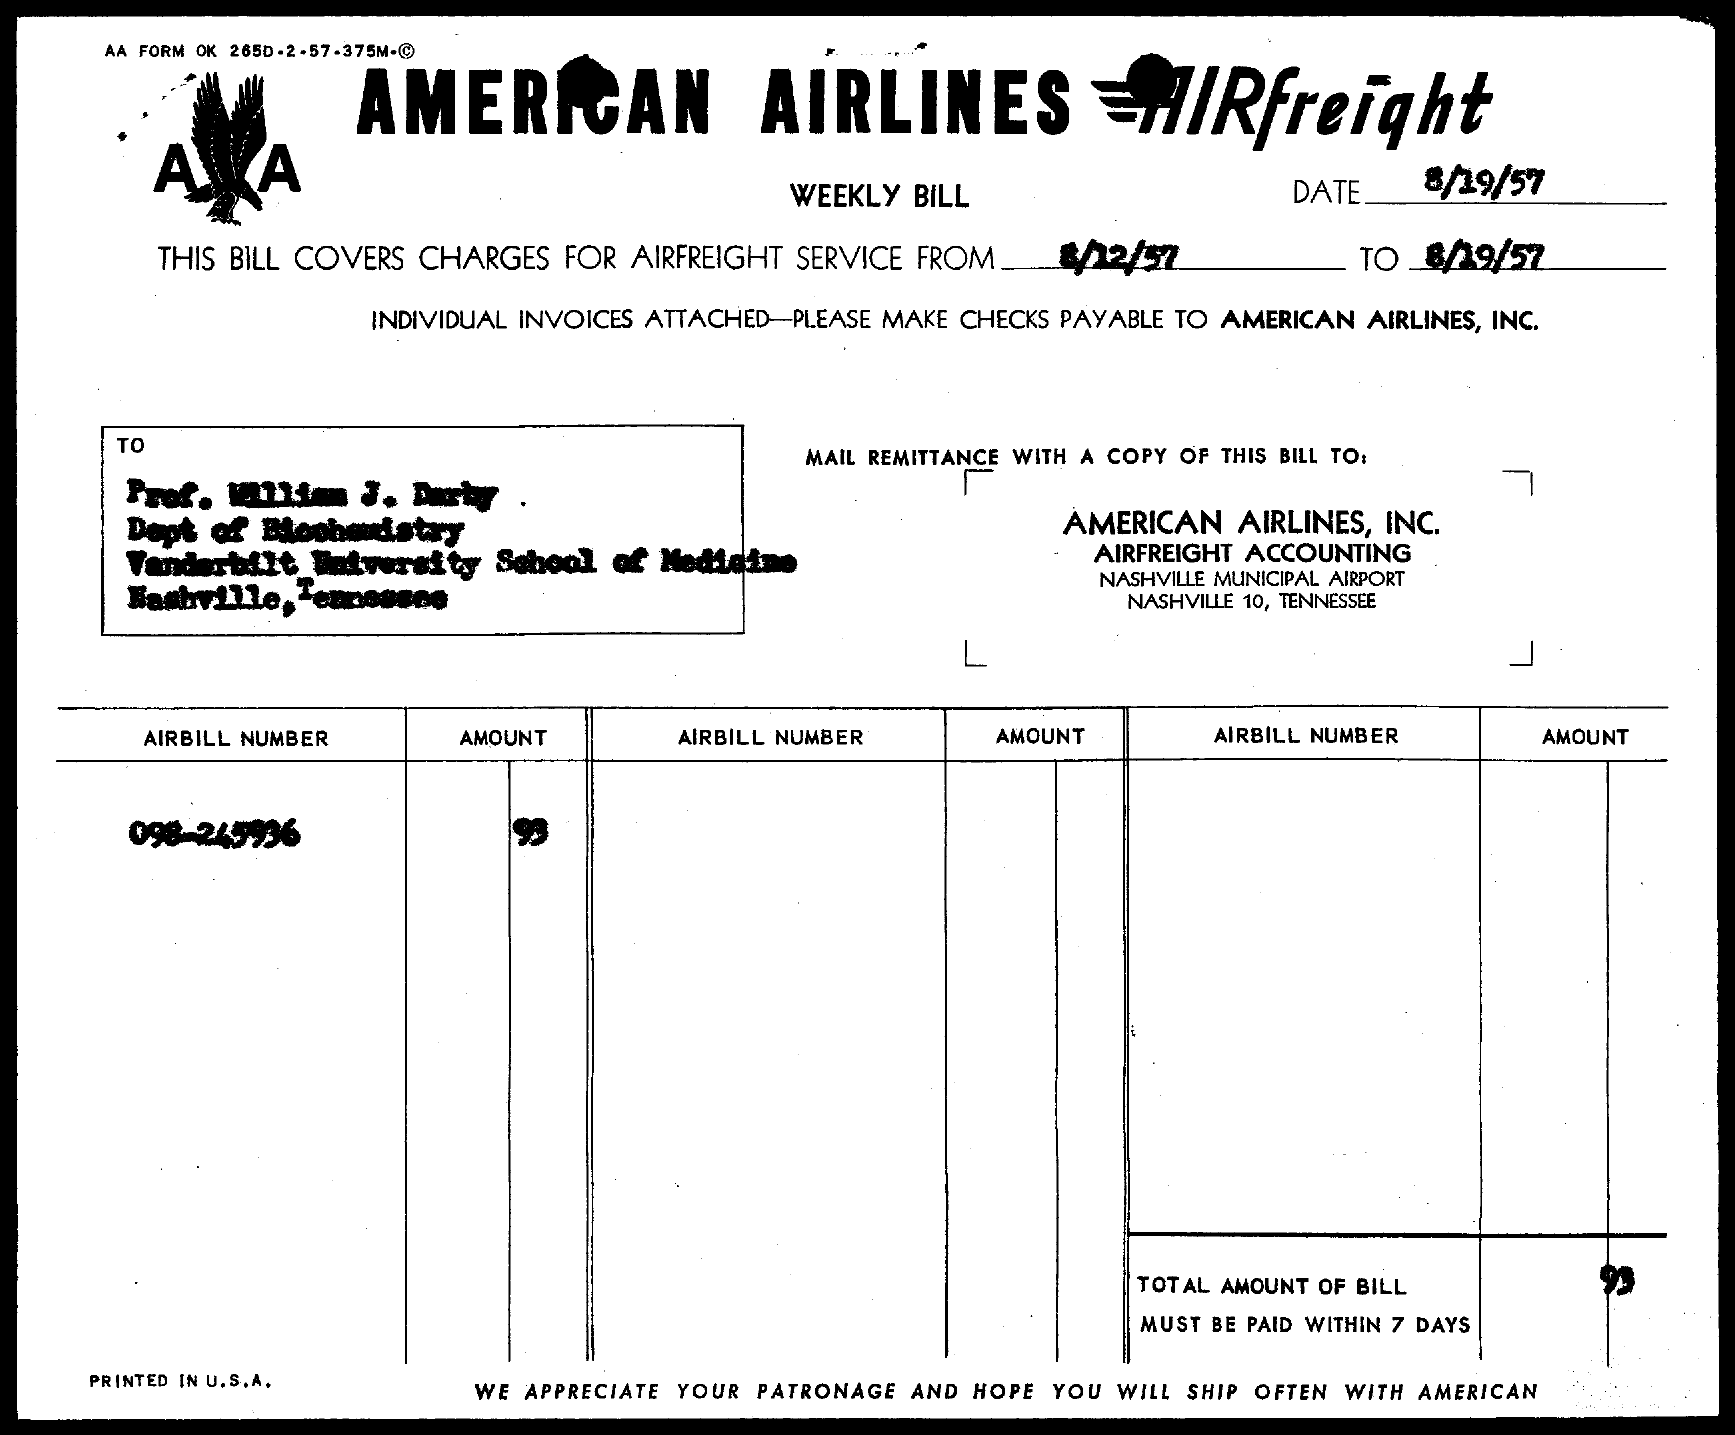What is the total amount of bill?
Offer a very short reply. 93. What is the AirBill Number?
Your response must be concise. 098-245936. 